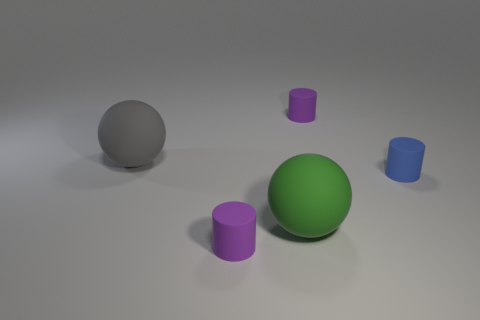Add 5 red matte cylinders. How many objects exist? 10 Subtract all cylinders. How many objects are left? 2 Subtract all small cyan shiny cylinders. Subtract all small blue things. How many objects are left? 4 Add 2 green objects. How many green objects are left? 3 Add 3 big green balls. How many big green balls exist? 4 Subtract 0 blue cubes. How many objects are left? 5 